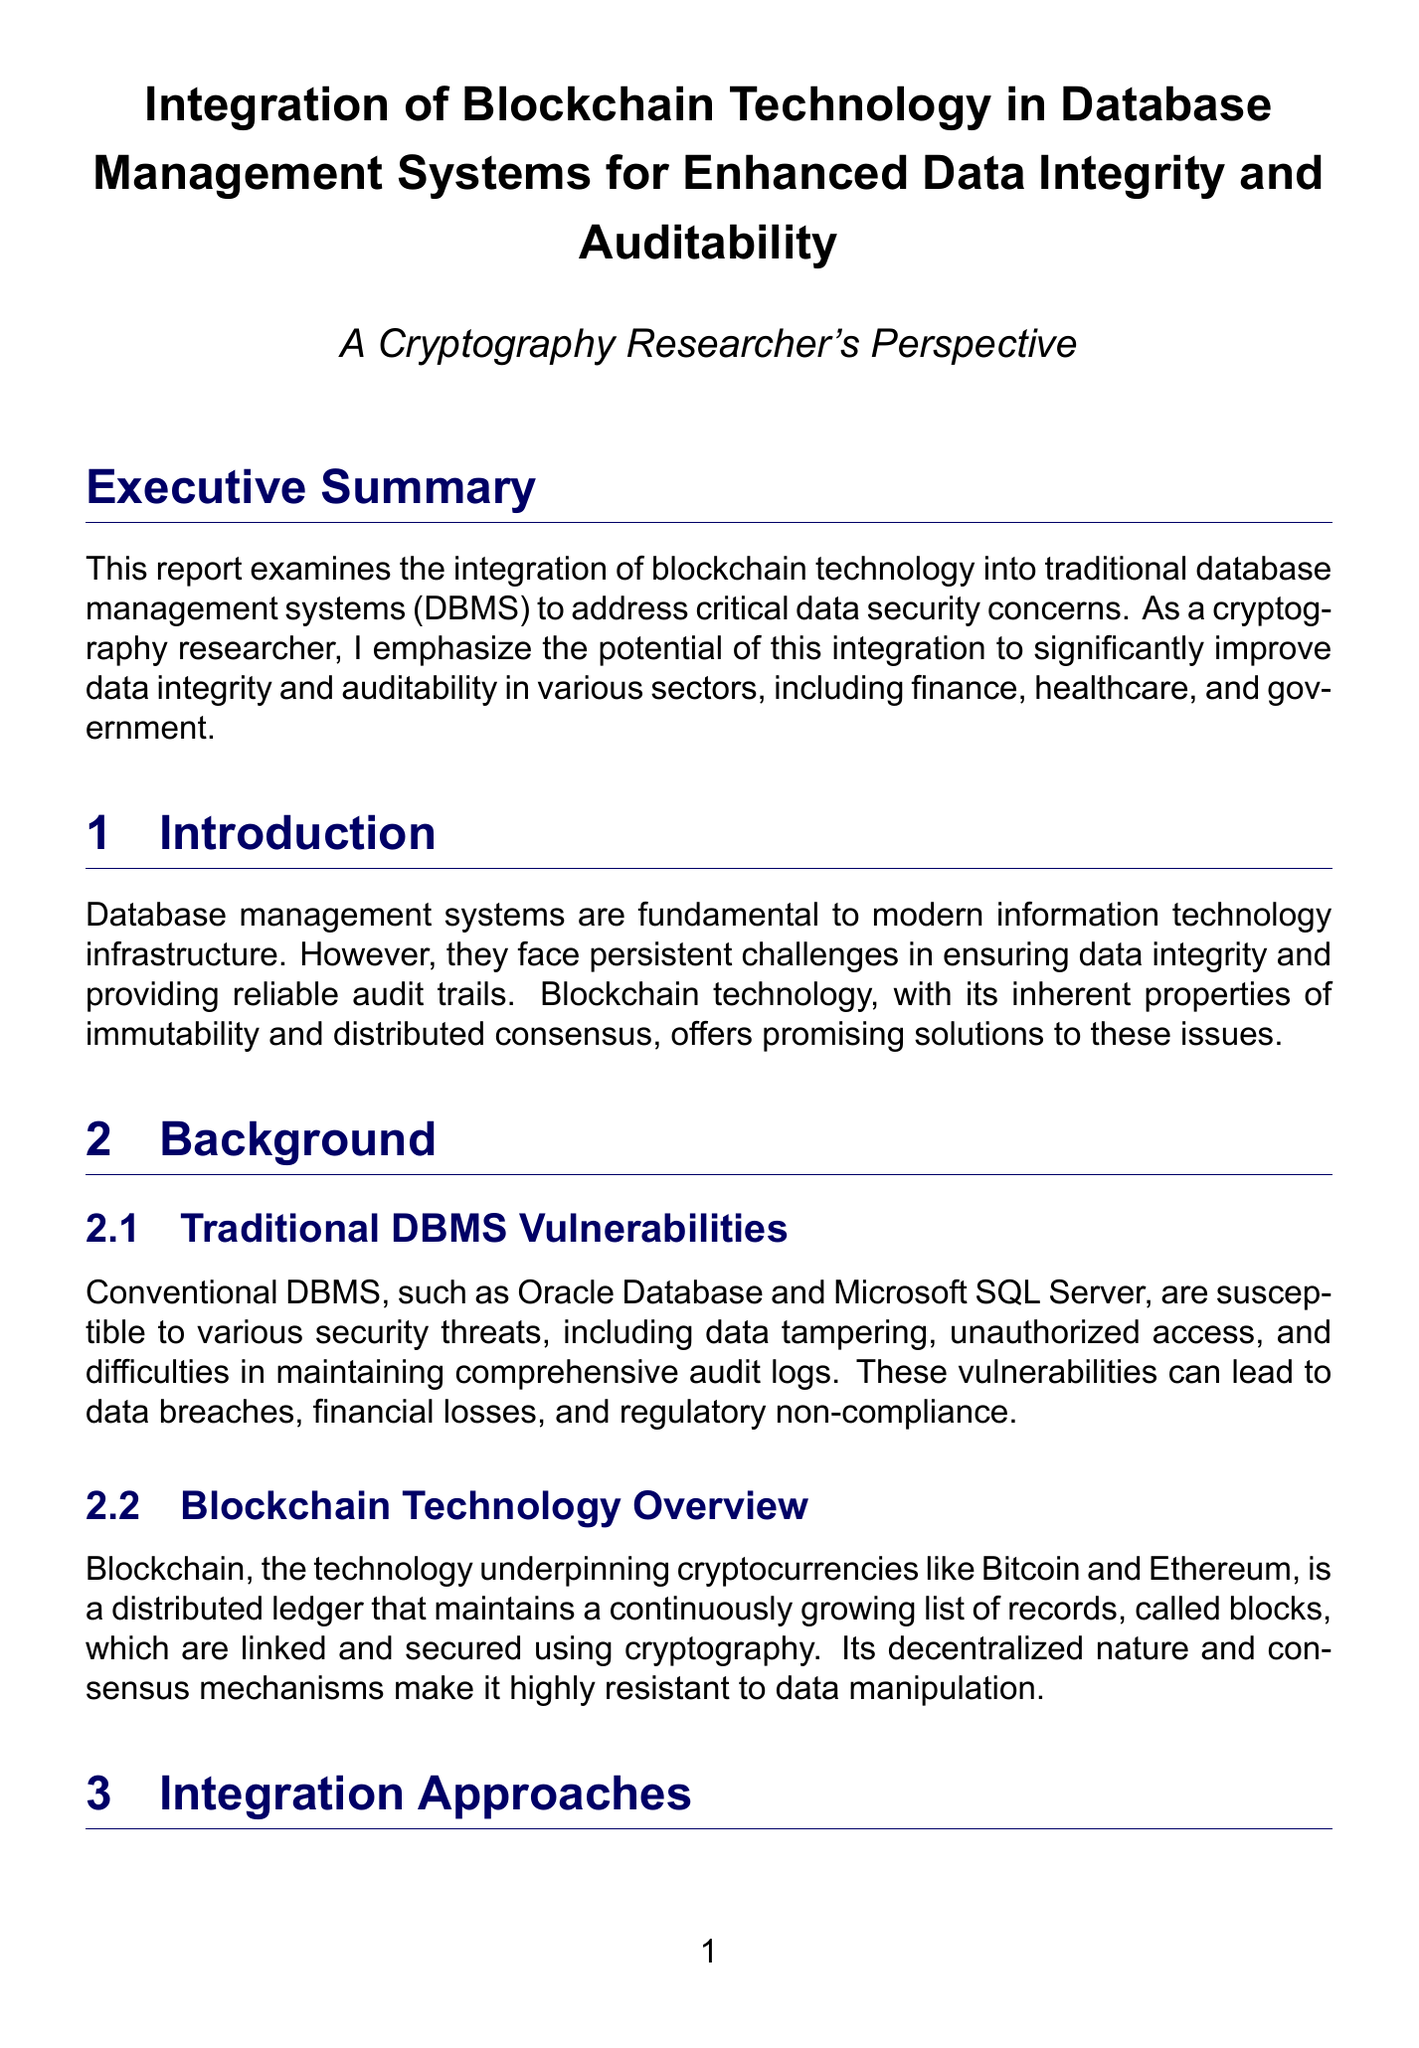What is the title of the report? The title of the report is indicated at the beginning of the document.
Answer: Integration of Blockchain Technology in Database Management Systems for Enhanced Data Integrity and Auditability What is one of the sectors highlighted in the executive summary? The executive summary mentions sectors where blockchain technology can improve data integrity.
Answer: finance What are hybrid systems? The report explains that hybrid systems combine DBMS with blockchain technology.
Answer: systems that combine traditional DBMS with blockchain What is one challenge mentioned regarding blockchain integration? The report outlines concerns that integrating blockchain with DBMS presents challenges.
Answer: scalability How has Walmart utilized blockchain technology? A case study discusses Walmart's implementation of a blockchain-based system.
Answer: to track its food supply chain What is the primary benefit of blockchain mentioned in the report? The report emphasizes the advantage of blockchain technology's characteristics.
Answer: enhanced data integrity Which cloud providers offer Blockchain as a Service? Information in the integration approaches section identifies specific cloud providers.
Answer: Amazon Web Services and Microsoft Azure What project did HSBC develop related to blockchain? The report details HSBC's specific blockchain project in its case studies section.
Answer: Voltron What is mentioned as a future direction for blockchain integration? The report discusses potential improvements and developments for blockchain and DBMS.
Answer: efficient consensus algorithms 